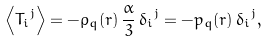Convert formula to latex. <formula><loc_0><loc_0><loc_500><loc_500>\left \langle { T _ { i } } ^ { j } \right \rangle = - \rho _ { q } ( r ) \, \frac { \alpha } { 3 } \, { \delta _ { i } } ^ { j } = - p _ { q } ( r ) \, { \delta _ { i } } ^ { j } ,</formula> 